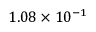<formula> <loc_0><loc_0><loc_500><loc_500>1 . 0 8 \times 1 0 ^ { - 1 }</formula> 